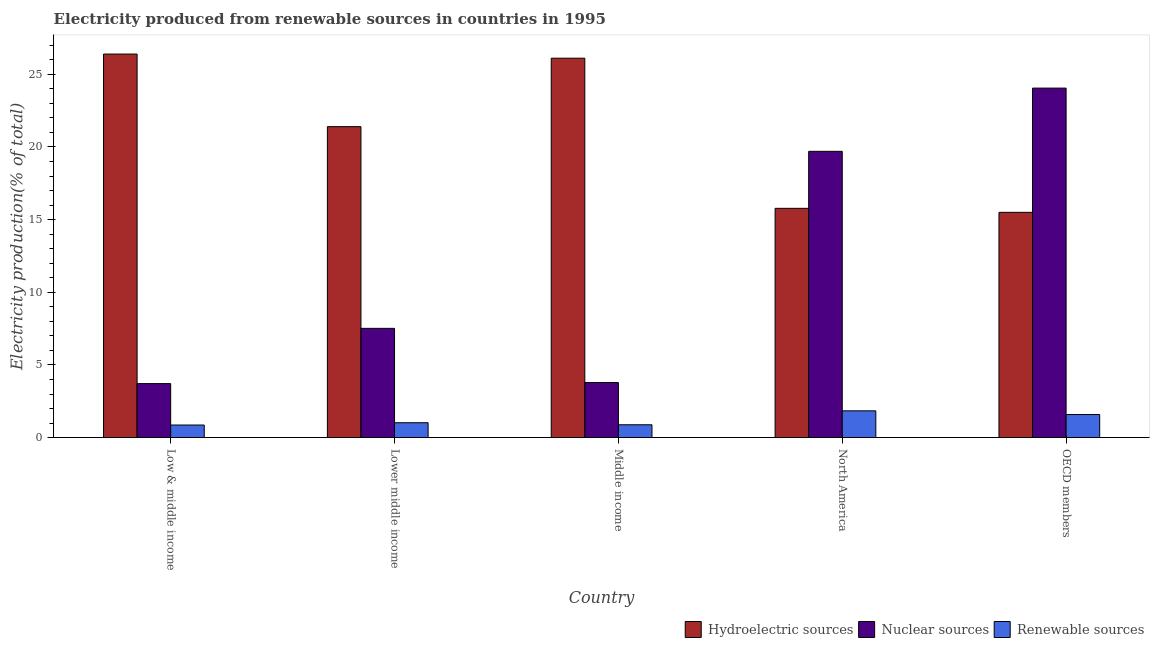How many groups of bars are there?
Offer a very short reply. 5. Are the number of bars per tick equal to the number of legend labels?
Provide a short and direct response. Yes. How many bars are there on the 5th tick from the left?
Give a very brief answer. 3. How many bars are there on the 3rd tick from the right?
Ensure brevity in your answer.  3. What is the label of the 3rd group of bars from the left?
Keep it short and to the point. Middle income. What is the percentage of electricity produced by nuclear sources in Middle income?
Your answer should be compact. 3.79. Across all countries, what is the maximum percentage of electricity produced by renewable sources?
Ensure brevity in your answer.  1.84. Across all countries, what is the minimum percentage of electricity produced by renewable sources?
Offer a terse response. 0.87. In which country was the percentage of electricity produced by hydroelectric sources maximum?
Ensure brevity in your answer.  Low & middle income. In which country was the percentage of electricity produced by renewable sources minimum?
Give a very brief answer. Low & middle income. What is the total percentage of electricity produced by hydroelectric sources in the graph?
Provide a succinct answer. 105.17. What is the difference between the percentage of electricity produced by nuclear sources in Low & middle income and that in Middle income?
Give a very brief answer. -0.07. What is the difference between the percentage of electricity produced by hydroelectric sources in Lower middle income and the percentage of electricity produced by renewable sources in Middle income?
Offer a terse response. 20.51. What is the average percentage of electricity produced by renewable sources per country?
Make the answer very short. 1.24. What is the difference between the percentage of electricity produced by hydroelectric sources and percentage of electricity produced by nuclear sources in North America?
Your answer should be very brief. -3.92. In how many countries, is the percentage of electricity produced by nuclear sources greater than 16 %?
Your answer should be very brief. 2. What is the ratio of the percentage of electricity produced by nuclear sources in Lower middle income to that in North America?
Your answer should be very brief. 0.38. Is the percentage of electricity produced by renewable sources in Low & middle income less than that in OECD members?
Offer a very short reply. Yes. Is the difference between the percentage of electricity produced by nuclear sources in Lower middle income and Middle income greater than the difference between the percentage of electricity produced by renewable sources in Lower middle income and Middle income?
Provide a succinct answer. Yes. What is the difference between the highest and the second highest percentage of electricity produced by hydroelectric sources?
Keep it short and to the point. 0.29. What is the difference between the highest and the lowest percentage of electricity produced by hydroelectric sources?
Provide a succinct answer. 10.89. In how many countries, is the percentage of electricity produced by nuclear sources greater than the average percentage of electricity produced by nuclear sources taken over all countries?
Your answer should be compact. 2. Is the sum of the percentage of electricity produced by nuclear sources in Middle income and OECD members greater than the maximum percentage of electricity produced by hydroelectric sources across all countries?
Provide a short and direct response. Yes. What does the 1st bar from the left in OECD members represents?
Keep it short and to the point. Hydroelectric sources. What does the 1st bar from the right in OECD members represents?
Your answer should be compact. Renewable sources. How many countries are there in the graph?
Keep it short and to the point. 5. What is the difference between two consecutive major ticks on the Y-axis?
Keep it short and to the point. 5. Does the graph contain any zero values?
Provide a short and direct response. No. Does the graph contain grids?
Provide a succinct answer. No. Where does the legend appear in the graph?
Ensure brevity in your answer.  Bottom right. How many legend labels are there?
Make the answer very short. 3. What is the title of the graph?
Your response must be concise. Electricity produced from renewable sources in countries in 1995. What is the label or title of the X-axis?
Offer a terse response. Country. What is the label or title of the Y-axis?
Keep it short and to the point. Electricity production(% of total). What is the Electricity production(% of total) in Hydroelectric sources in Low & middle income?
Provide a succinct answer. 26.39. What is the Electricity production(% of total) in Nuclear sources in Low & middle income?
Provide a succinct answer. 3.72. What is the Electricity production(% of total) of Renewable sources in Low & middle income?
Provide a succinct answer. 0.87. What is the Electricity production(% of total) in Hydroelectric sources in Lower middle income?
Offer a terse response. 21.4. What is the Electricity production(% of total) of Nuclear sources in Lower middle income?
Give a very brief answer. 7.52. What is the Electricity production(% of total) in Renewable sources in Lower middle income?
Your answer should be compact. 1.02. What is the Electricity production(% of total) in Hydroelectric sources in Middle income?
Ensure brevity in your answer.  26.11. What is the Electricity production(% of total) of Nuclear sources in Middle income?
Provide a succinct answer. 3.79. What is the Electricity production(% of total) of Renewable sources in Middle income?
Provide a short and direct response. 0.88. What is the Electricity production(% of total) in Hydroelectric sources in North America?
Provide a succinct answer. 15.78. What is the Electricity production(% of total) in Nuclear sources in North America?
Your answer should be very brief. 19.7. What is the Electricity production(% of total) in Renewable sources in North America?
Provide a short and direct response. 1.84. What is the Electricity production(% of total) in Hydroelectric sources in OECD members?
Offer a terse response. 15.5. What is the Electricity production(% of total) in Nuclear sources in OECD members?
Offer a terse response. 24.05. What is the Electricity production(% of total) in Renewable sources in OECD members?
Keep it short and to the point. 1.59. Across all countries, what is the maximum Electricity production(% of total) in Hydroelectric sources?
Give a very brief answer. 26.39. Across all countries, what is the maximum Electricity production(% of total) of Nuclear sources?
Make the answer very short. 24.05. Across all countries, what is the maximum Electricity production(% of total) of Renewable sources?
Provide a short and direct response. 1.84. Across all countries, what is the minimum Electricity production(% of total) in Hydroelectric sources?
Provide a succinct answer. 15.5. Across all countries, what is the minimum Electricity production(% of total) of Nuclear sources?
Give a very brief answer. 3.72. Across all countries, what is the minimum Electricity production(% of total) in Renewable sources?
Offer a terse response. 0.87. What is the total Electricity production(% of total) of Hydroelectric sources in the graph?
Keep it short and to the point. 105.17. What is the total Electricity production(% of total) in Nuclear sources in the graph?
Your answer should be compact. 58.77. What is the total Electricity production(% of total) in Renewable sources in the graph?
Provide a succinct answer. 6.21. What is the difference between the Electricity production(% of total) of Hydroelectric sources in Low & middle income and that in Lower middle income?
Provide a succinct answer. 5. What is the difference between the Electricity production(% of total) of Nuclear sources in Low & middle income and that in Lower middle income?
Make the answer very short. -3.8. What is the difference between the Electricity production(% of total) in Renewable sources in Low & middle income and that in Lower middle income?
Provide a succinct answer. -0.16. What is the difference between the Electricity production(% of total) in Hydroelectric sources in Low & middle income and that in Middle income?
Keep it short and to the point. 0.29. What is the difference between the Electricity production(% of total) in Nuclear sources in Low & middle income and that in Middle income?
Provide a succinct answer. -0.07. What is the difference between the Electricity production(% of total) in Renewable sources in Low & middle income and that in Middle income?
Your response must be concise. -0.02. What is the difference between the Electricity production(% of total) in Hydroelectric sources in Low & middle income and that in North America?
Keep it short and to the point. 10.62. What is the difference between the Electricity production(% of total) of Nuclear sources in Low & middle income and that in North America?
Ensure brevity in your answer.  -15.98. What is the difference between the Electricity production(% of total) of Renewable sources in Low & middle income and that in North America?
Provide a short and direct response. -0.98. What is the difference between the Electricity production(% of total) of Hydroelectric sources in Low & middle income and that in OECD members?
Offer a very short reply. 10.89. What is the difference between the Electricity production(% of total) of Nuclear sources in Low & middle income and that in OECD members?
Provide a short and direct response. -20.33. What is the difference between the Electricity production(% of total) of Renewable sources in Low & middle income and that in OECD members?
Ensure brevity in your answer.  -0.72. What is the difference between the Electricity production(% of total) in Hydroelectric sources in Lower middle income and that in Middle income?
Give a very brief answer. -4.71. What is the difference between the Electricity production(% of total) of Nuclear sources in Lower middle income and that in Middle income?
Offer a very short reply. 3.73. What is the difference between the Electricity production(% of total) of Renewable sources in Lower middle income and that in Middle income?
Provide a succinct answer. 0.14. What is the difference between the Electricity production(% of total) of Hydroelectric sources in Lower middle income and that in North America?
Give a very brief answer. 5.62. What is the difference between the Electricity production(% of total) of Nuclear sources in Lower middle income and that in North America?
Provide a short and direct response. -12.18. What is the difference between the Electricity production(% of total) in Renewable sources in Lower middle income and that in North America?
Provide a succinct answer. -0.82. What is the difference between the Electricity production(% of total) in Hydroelectric sources in Lower middle income and that in OECD members?
Your answer should be very brief. 5.9. What is the difference between the Electricity production(% of total) of Nuclear sources in Lower middle income and that in OECD members?
Ensure brevity in your answer.  -16.53. What is the difference between the Electricity production(% of total) in Renewable sources in Lower middle income and that in OECD members?
Your response must be concise. -0.56. What is the difference between the Electricity production(% of total) of Hydroelectric sources in Middle income and that in North America?
Provide a succinct answer. 10.33. What is the difference between the Electricity production(% of total) in Nuclear sources in Middle income and that in North America?
Your response must be concise. -15.91. What is the difference between the Electricity production(% of total) of Renewable sources in Middle income and that in North America?
Your answer should be very brief. -0.96. What is the difference between the Electricity production(% of total) of Hydroelectric sources in Middle income and that in OECD members?
Offer a terse response. 10.61. What is the difference between the Electricity production(% of total) of Nuclear sources in Middle income and that in OECD members?
Your answer should be compact. -20.26. What is the difference between the Electricity production(% of total) in Renewable sources in Middle income and that in OECD members?
Offer a very short reply. -0.7. What is the difference between the Electricity production(% of total) in Hydroelectric sources in North America and that in OECD members?
Provide a succinct answer. 0.28. What is the difference between the Electricity production(% of total) in Nuclear sources in North America and that in OECD members?
Your response must be concise. -4.35. What is the difference between the Electricity production(% of total) in Renewable sources in North America and that in OECD members?
Provide a succinct answer. 0.25. What is the difference between the Electricity production(% of total) of Hydroelectric sources in Low & middle income and the Electricity production(% of total) of Nuclear sources in Lower middle income?
Keep it short and to the point. 18.87. What is the difference between the Electricity production(% of total) in Hydroelectric sources in Low & middle income and the Electricity production(% of total) in Renewable sources in Lower middle income?
Your response must be concise. 25.37. What is the difference between the Electricity production(% of total) in Nuclear sources in Low & middle income and the Electricity production(% of total) in Renewable sources in Lower middle income?
Offer a very short reply. 2.69. What is the difference between the Electricity production(% of total) of Hydroelectric sources in Low & middle income and the Electricity production(% of total) of Nuclear sources in Middle income?
Provide a succinct answer. 22.6. What is the difference between the Electricity production(% of total) in Hydroelectric sources in Low & middle income and the Electricity production(% of total) in Renewable sources in Middle income?
Keep it short and to the point. 25.51. What is the difference between the Electricity production(% of total) of Nuclear sources in Low & middle income and the Electricity production(% of total) of Renewable sources in Middle income?
Offer a very short reply. 2.83. What is the difference between the Electricity production(% of total) in Hydroelectric sources in Low & middle income and the Electricity production(% of total) in Nuclear sources in North America?
Provide a short and direct response. 6.69. What is the difference between the Electricity production(% of total) of Hydroelectric sources in Low & middle income and the Electricity production(% of total) of Renewable sources in North America?
Keep it short and to the point. 24.55. What is the difference between the Electricity production(% of total) of Nuclear sources in Low & middle income and the Electricity production(% of total) of Renewable sources in North America?
Offer a very short reply. 1.87. What is the difference between the Electricity production(% of total) of Hydroelectric sources in Low & middle income and the Electricity production(% of total) of Nuclear sources in OECD members?
Offer a very short reply. 2.34. What is the difference between the Electricity production(% of total) of Hydroelectric sources in Low & middle income and the Electricity production(% of total) of Renewable sources in OECD members?
Your response must be concise. 24.8. What is the difference between the Electricity production(% of total) of Nuclear sources in Low & middle income and the Electricity production(% of total) of Renewable sources in OECD members?
Provide a short and direct response. 2.13. What is the difference between the Electricity production(% of total) of Hydroelectric sources in Lower middle income and the Electricity production(% of total) of Nuclear sources in Middle income?
Keep it short and to the point. 17.61. What is the difference between the Electricity production(% of total) of Hydroelectric sources in Lower middle income and the Electricity production(% of total) of Renewable sources in Middle income?
Keep it short and to the point. 20.51. What is the difference between the Electricity production(% of total) in Nuclear sources in Lower middle income and the Electricity production(% of total) in Renewable sources in Middle income?
Your answer should be very brief. 6.64. What is the difference between the Electricity production(% of total) in Hydroelectric sources in Lower middle income and the Electricity production(% of total) in Nuclear sources in North America?
Offer a very short reply. 1.7. What is the difference between the Electricity production(% of total) of Hydroelectric sources in Lower middle income and the Electricity production(% of total) of Renewable sources in North America?
Your response must be concise. 19.55. What is the difference between the Electricity production(% of total) in Nuclear sources in Lower middle income and the Electricity production(% of total) in Renewable sources in North America?
Give a very brief answer. 5.68. What is the difference between the Electricity production(% of total) in Hydroelectric sources in Lower middle income and the Electricity production(% of total) in Nuclear sources in OECD members?
Give a very brief answer. -2.65. What is the difference between the Electricity production(% of total) of Hydroelectric sources in Lower middle income and the Electricity production(% of total) of Renewable sources in OECD members?
Provide a succinct answer. 19.81. What is the difference between the Electricity production(% of total) in Nuclear sources in Lower middle income and the Electricity production(% of total) in Renewable sources in OECD members?
Provide a succinct answer. 5.93. What is the difference between the Electricity production(% of total) in Hydroelectric sources in Middle income and the Electricity production(% of total) in Nuclear sources in North America?
Give a very brief answer. 6.41. What is the difference between the Electricity production(% of total) in Hydroelectric sources in Middle income and the Electricity production(% of total) in Renewable sources in North America?
Keep it short and to the point. 24.26. What is the difference between the Electricity production(% of total) in Nuclear sources in Middle income and the Electricity production(% of total) in Renewable sources in North America?
Ensure brevity in your answer.  1.95. What is the difference between the Electricity production(% of total) of Hydroelectric sources in Middle income and the Electricity production(% of total) of Nuclear sources in OECD members?
Your response must be concise. 2.06. What is the difference between the Electricity production(% of total) of Hydroelectric sources in Middle income and the Electricity production(% of total) of Renewable sources in OECD members?
Offer a terse response. 24.52. What is the difference between the Electricity production(% of total) of Nuclear sources in Middle income and the Electricity production(% of total) of Renewable sources in OECD members?
Make the answer very short. 2.2. What is the difference between the Electricity production(% of total) of Hydroelectric sources in North America and the Electricity production(% of total) of Nuclear sources in OECD members?
Your answer should be very brief. -8.27. What is the difference between the Electricity production(% of total) in Hydroelectric sources in North America and the Electricity production(% of total) in Renewable sources in OECD members?
Your response must be concise. 14.19. What is the difference between the Electricity production(% of total) in Nuclear sources in North America and the Electricity production(% of total) in Renewable sources in OECD members?
Offer a terse response. 18.11. What is the average Electricity production(% of total) in Hydroelectric sources per country?
Offer a terse response. 21.03. What is the average Electricity production(% of total) in Nuclear sources per country?
Provide a short and direct response. 11.75. What is the average Electricity production(% of total) of Renewable sources per country?
Provide a succinct answer. 1.24. What is the difference between the Electricity production(% of total) in Hydroelectric sources and Electricity production(% of total) in Nuclear sources in Low & middle income?
Provide a succinct answer. 22.68. What is the difference between the Electricity production(% of total) of Hydroelectric sources and Electricity production(% of total) of Renewable sources in Low & middle income?
Your response must be concise. 25.53. What is the difference between the Electricity production(% of total) in Nuclear sources and Electricity production(% of total) in Renewable sources in Low & middle income?
Offer a terse response. 2.85. What is the difference between the Electricity production(% of total) of Hydroelectric sources and Electricity production(% of total) of Nuclear sources in Lower middle income?
Ensure brevity in your answer.  13.88. What is the difference between the Electricity production(% of total) in Hydroelectric sources and Electricity production(% of total) in Renewable sources in Lower middle income?
Make the answer very short. 20.37. What is the difference between the Electricity production(% of total) in Nuclear sources and Electricity production(% of total) in Renewable sources in Lower middle income?
Offer a terse response. 6.49. What is the difference between the Electricity production(% of total) in Hydroelectric sources and Electricity production(% of total) in Nuclear sources in Middle income?
Keep it short and to the point. 22.32. What is the difference between the Electricity production(% of total) in Hydroelectric sources and Electricity production(% of total) in Renewable sources in Middle income?
Give a very brief answer. 25.22. What is the difference between the Electricity production(% of total) in Nuclear sources and Electricity production(% of total) in Renewable sources in Middle income?
Give a very brief answer. 2.9. What is the difference between the Electricity production(% of total) in Hydroelectric sources and Electricity production(% of total) in Nuclear sources in North America?
Offer a very short reply. -3.92. What is the difference between the Electricity production(% of total) in Hydroelectric sources and Electricity production(% of total) in Renewable sources in North America?
Ensure brevity in your answer.  13.93. What is the difference between the Electricity production(% of total) of Nuclear sources and Electricity production(% of total) of Renewable sources in North America?
Make the answer very short. 17.86. What is the difference between the Electricity production(% of total) of Hydroelectric sources and Electricity production(% of total) of Nuclear sources in OECD members?
Your answer should be very brief. -8.55. What is the difference between the Electricity production(% of total) in Hydroelectric sources and Electricity production(% of total) in Renewable sources in OECD members?
Your answer should be compact. 13.91. What is the difference between the Electricity production(% of total) in Nuclear sources and Electricity production(% of total) in Renewable sources in OECD members?
Make the answer very short. 22.46. What is the ratio of the Electricity production(% of total) in Hydroelectric sources in Low & middle income to that in Lower middle income?
Give a very brief answer. 1.23. What is the ratio of the Electricity production(% of total) of Nuclear sources in Low & middle income to that in Lower middle income?
Provide a short and direct response. 0.49. What is the ratio of the Electricity production(% of total) in Renewable sources in Low & middle income to that in Lower middle income?
Keep it short and to the point. 0.85. What is the ratio of the Electricity production(% of total) in Hydroelectric sources in Low & middle income to that in Middle income?
Make the answer very short. 1.01. What is the ratio of the Electricity production(% of total) in Hydroelectric sources in Low & middle income to that in North America?
Your answer should be compact. 1.67. What is the ratio of the Electricity production(% of total) in Nuclear sources in Low & middle income to that in North America?
Provide a succinct answer. 0.19. What is the ratio of the Electricity production(% of total) in Renewable sources in Low & middle income to that in North America?
Your response must be concise. 0.47. What is the ratio of the Electricity production(% of total) of Hydroelectric sources in Low & middle income to that in OECD members?
Offer a terse response. 1.7. What is the ratio of the Electricity production(% of total) of Nuclear sources in Low & middle income to that in OECD members?
Your answer should be compact. 0.15. What is the ratio of the Electricity production(% of total) in Renewable sources in Low & middle income to that in OECD members?
Offer a very short reply. 0.55. What is the ratio of the Electricity production(% of total) in Hydroelectric sources in Lower middle income to that in Middle income?
Provide a succinct answer. 0.82. What is the ratio of the Electricity production(% of total) of Nuclear sources in Lower middle income to that in Middle income?
Your answer should be very brief. 1.98. What is the ratio of the Electricity production(% of total) of Renewable sources in Lower middle income to that in Middle income?
Ensure brevity in your answer.  1.16. What is the ratio of the Electricity production(% of total) in Hydroelectric sources in Lower middle income to that in North America?
Give a very brief answer. 1.36. What is the ratio of the Electricity production(% of total) of Nuclear sources in Lower middle income to that in North America?
Give a very brief answer. 0.38. What is the ratio of the Electricity production(% of total) of Renewable sources in Lower middle income to that in North America?
Give a very brief answer. 0.56. What is the ratio of the Electricity production(% of total) in Hydroelectric sources in Lower middle income to that in OECD members?
Give a very brief answer. 1.38. What is the ratio of the Electricity production(% of total) of Nuclear sources in Lower middle income to that in OECD members?
Keep it short and to the point. 0.31. What is the ratio of the Electricity production(% of total) in Renewable sources in Lower middle income to that in OECD members?
Your answer should be compact. 0.65. What is the ratio of the Electricity production(% of total) of Hydroelectric sources in Middle income to that in North America?
Offer a very short reply. 1.65. What is the ratio of the Electricity production(% of total) of Nuclear sources in Middle income to that in North America?
Offer a very short reply. 0.19. What is the ratio of the Electricity production(% of total) in Renewable sources in Middle income to that in North America?
Ensure brevity in your answer.  0.48. What is the ratio of the Electricity production(% of total) in Hydroelectric sources in Middle income to that in OECD members?
Give a very brief answer. 1.68. What is the ratio of the Electricity production(% of total) of Nuclear sources in Middle income to that in OECD members?
Ensure brevity in your answer.  0.16. What is the ratio of the Electricity production(% of total) of Renewable sources in Middle income to that in OECD members?
Provide a short and direct response. 0.56. What is the ratio of the Electricity production(% of total) in Hydroelectric sources in North America to that in OECD members?
Your answer should be very brief. 1.02. What is the ratio of the Electricity production(% of total) of Nuclear sources in North America to that in OECD members?
Give a very brief answer. 0.82. What is the ratio of the Electricity production(% of total) in Renewable sources in North America to that in OECD members?
Give a very brief answer. 1.16. What is the difference between the highest and the second highest Electricity production(% of total) of Hydroelectric sources?
Your answer should be very brief. 0.29. What is the difference between the highest and the second highest Electricity production(% of total) in Nuclear sources?
Give a very brief answer. 4.35. What is the difference between the highest and the second highest Electricity production(% of total) of Renewable sources?
Keep it short and to the point. 0.25. What is the difference between the highest and the lowest Electricity production(% of total) in Hydroelectric sources?
Ensure brevity in your answer.  10.89. What is the difference between the highest and the lowest Electricity production(% of total) in Nuclear sources?
Your response must be concise. 20.33. What is the difference between the highest and the lowest Electricity production(% of total) in Renewable sources?
Ensure brevity in your answer.  0.98. 